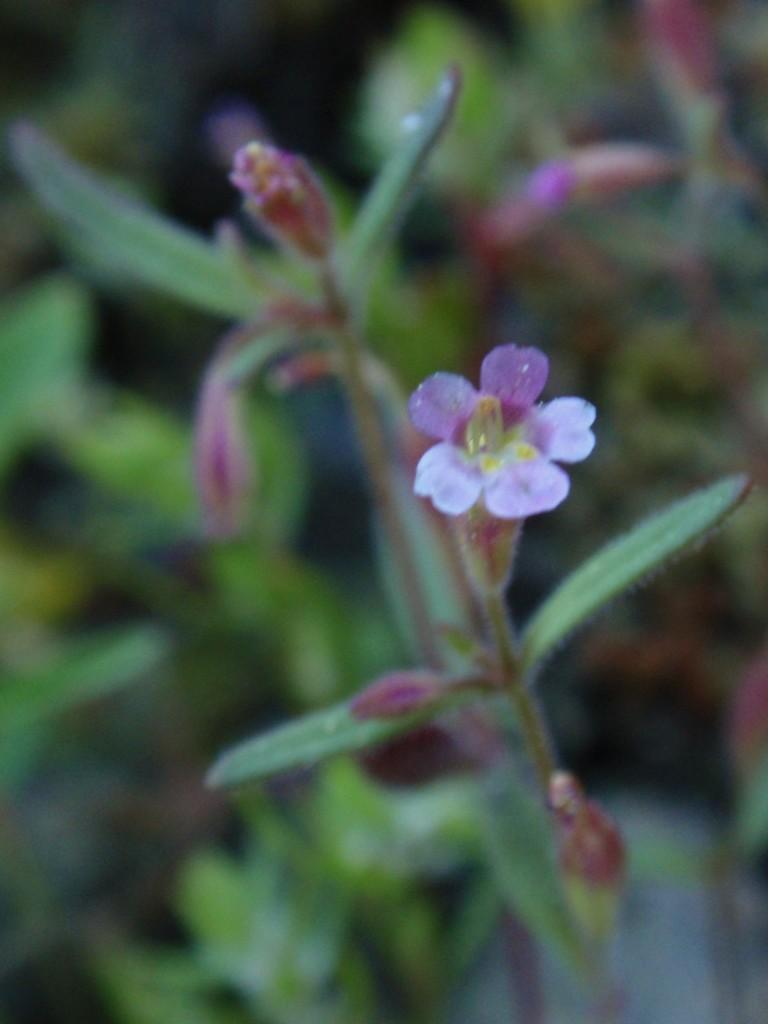What is the main subject of the image? There is a flower in the image. What colors can be seen on the flower? The flower has white, pink, and yellow colors. Are there any unopened parts on the plant? Yes, there are buds on the plant. How would you describe the background of the image? The background of the image is blurred. What type of shoe can be seen in the image? There is no shoe present in the image; it features a flower with buds. Is there any coal visible in the image? There is no coal present in the image; it features a flower with buds. 